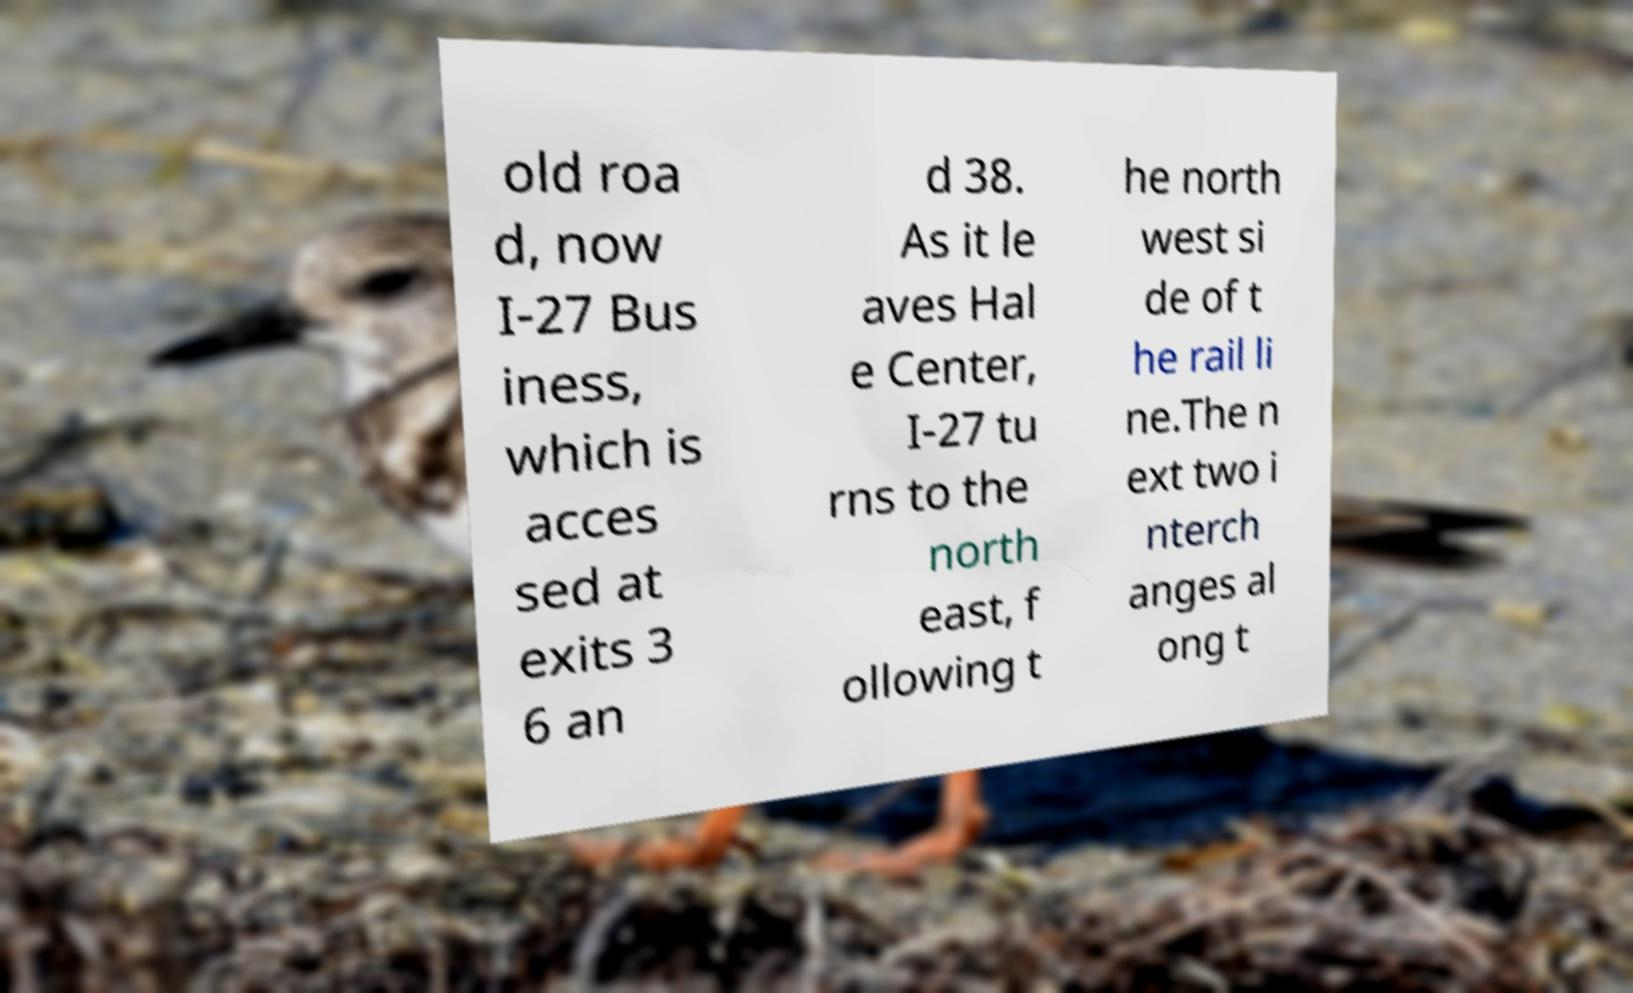What messages or text are displayed in this image? I need them in a readable, typed format. old roa d, now I-27 Bus iness, which is acces sed at exits 3 6 an d 38. As it le aves Hal e Center, I-27 tu rns to the north east, f ollowing t he north west si de of t he rail li ne.The n ext two i nterch anges al ong t 